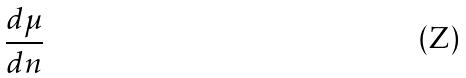<formula> <loc_0><loc_0><loc_500><loc_500>\frac { d \mu } { d n }</formula> 